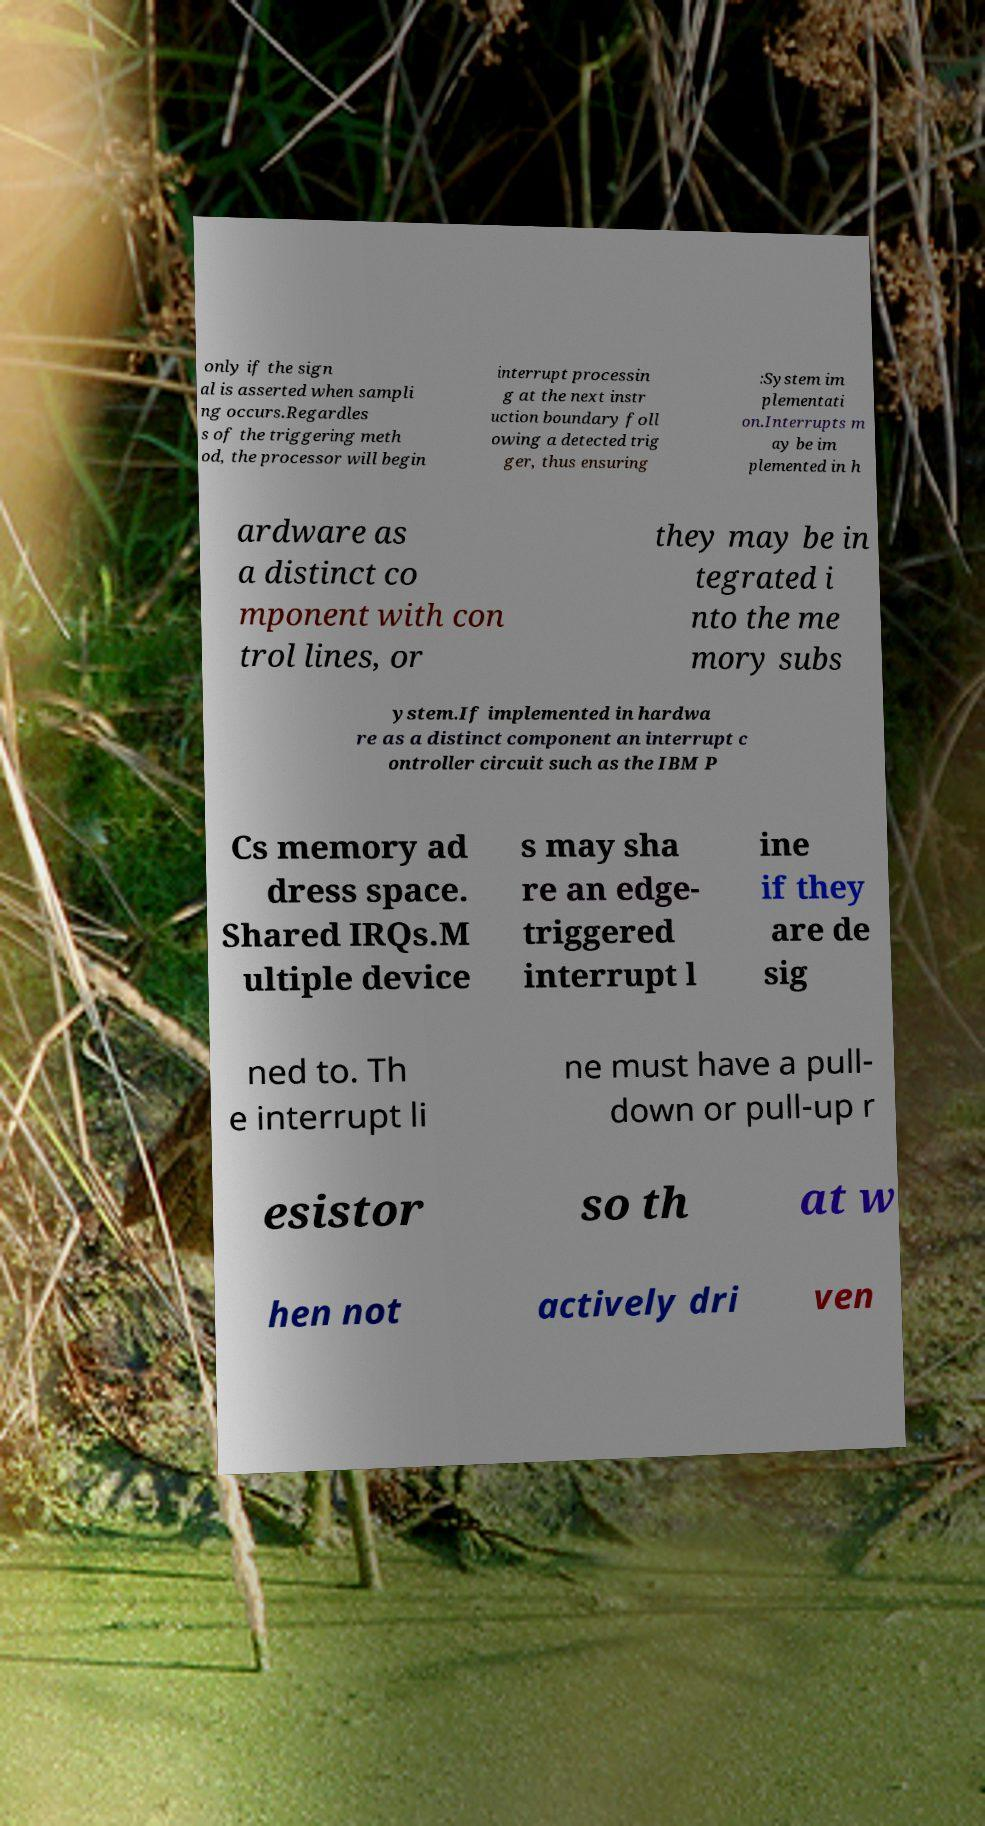Please identify and transcribe the text found in this image. only if the sign al is asserted when sampli ng occurs.Regardles s of the triggering meth od, the processor will begin interrupt processin g at the next instr uction boundary foll owing a detected trig ger, thus ensuring :System im plementati on.Interrupts m ay be im plemented in h ardware as a distinct co mponent with con trol lines, or they may be in tegrated i nto the me mory subs ystem.If implemented in hardwa re as a distinct component an interrupt c ontroller circuit such as the IBM P Cs memory ad dress space. Shared IRQs.M ultiple device s may sha re an edge- triggered interrupt l ine if they are de sig ned to. Th e interrupt li ne must have a pull- down or pull-up r esistor so th at w hen not actively dri ven 